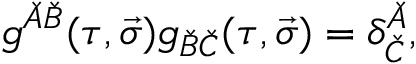Convert formula to latex. <formula><loc_0><loc_0><loc_500><loc_500>g ^ { \check { A } \check { B } } ( \tau , \vec { \sigma } ) g _ { \check { B } \check { C } } ( \tau , \vec { \sigma } ) = \delta _ { \check { C } } ^ { \check { A } } ,</formula> 